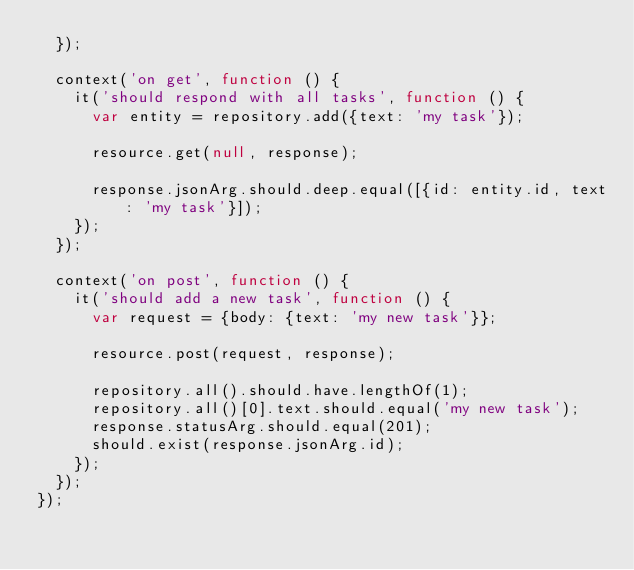<code> <loc_0><loc_0><loc_500><loc_500><_JavaScript_>  });

  context('on get', function () {
    it('should respond with all tasks', function () {
      var entity = repository.add({text: 'my task'});

      resource.get(null, response);

      response.jsonArg.should.deep.equal([{id: entity.id, text: 'my task'}]);
    });
  });

  context('on post', function () {
    it('should add a new task', function () {
      var request = {body: {text: 'my new task'}};

      resource.post(request, response);

      repository.all().should.have.lengthOf(1);
      repository.all()[0].text.should.equal('my new task');
      response.statusArg.should.equal(201);
      should.exist(response.jsonArg.id);
    });
  });
});
</code> 